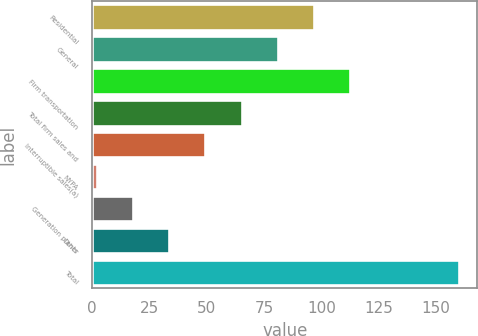<chart> <loc_0><loc_0><loc_500><loc_500><bar_chart><fcel>Residential<fcel>General<fcel>Firm transportation<fcel>Total firm sales and<fcel>Interruptible sales(a)<fcel>NYPA<fcel>Generation plants<fcel>Other<fcel>Total<nl><fcel>96.8<fcel>81<fcel>112.6<fcel>65.2<fcel>49.4<fcel>2<fcel>17.8<fcel>33.6<fcel>160<nl></chart> 